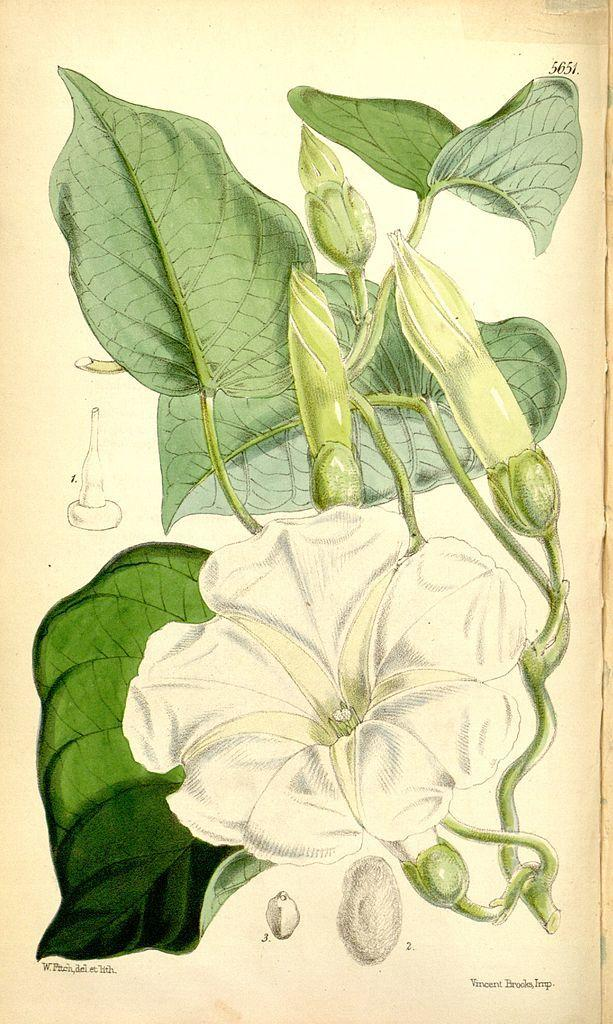What is the main subject of the art in the image? The main subject of the art in the image is a flower. What other elements are present in the art? There are leaves depicted in the art. What additional feature can be observed in the image? There are watermarks visible in the image. What type of butter is being used to create the art in the image? There is no butter present in the image; it is an art piece featuring a flower and leaves. 